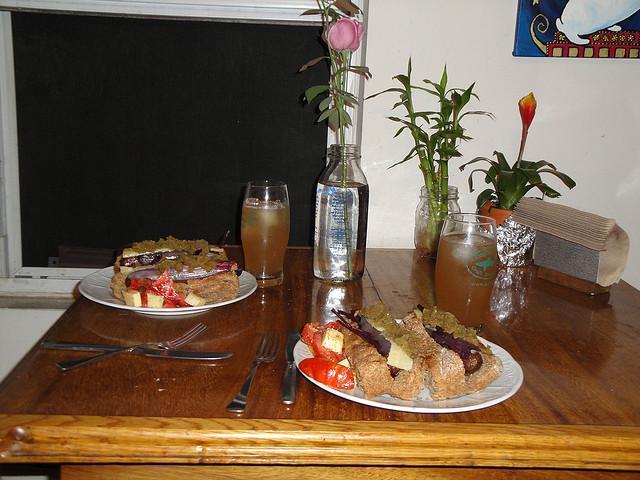How many hot dogs are in the photo?
Give a very brief answer. 4. How many cups are visible?
Give a very brief answer. 2. 